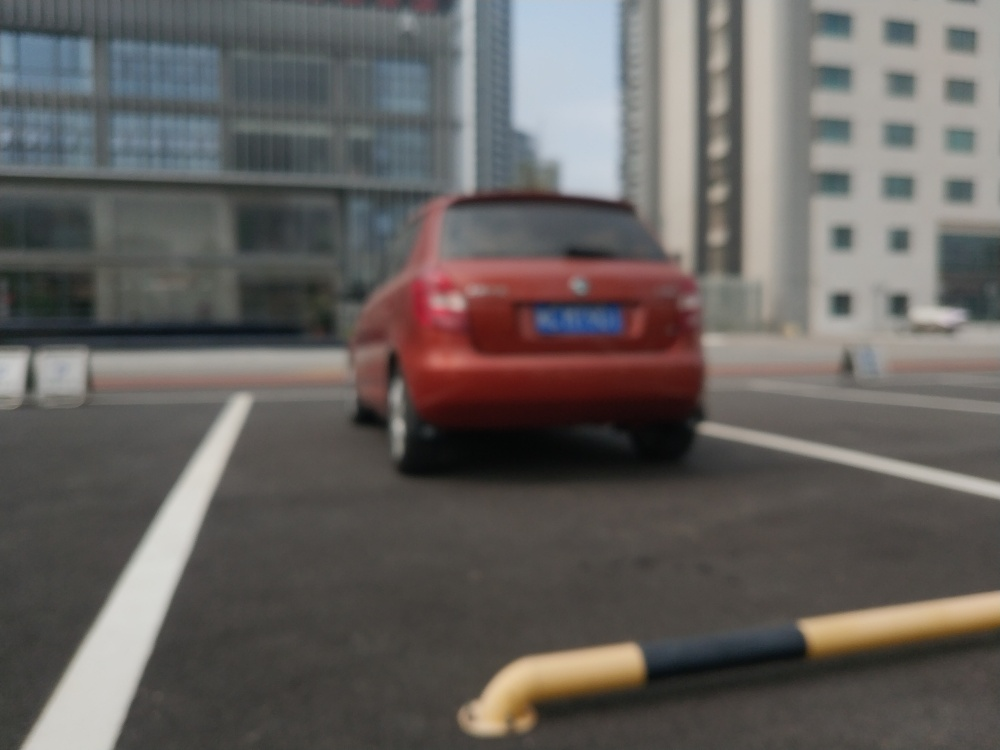How would you describe the texture details of the car? While the car's texture details are somewhat obscured due to the photo's blurriness, some contours and reflections are still perceptible. The image has a shallow depth of field that helps maintain a soft focus on the background, suggesting the photograph might have been taken intentionally this way to highlight or artistically represent the car. 